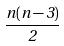Convert formula to latex. <formula><loc_0><loc_0><loc_500><loc_500>\frac { n ( n - 3 ) } { 2 }</formula> 